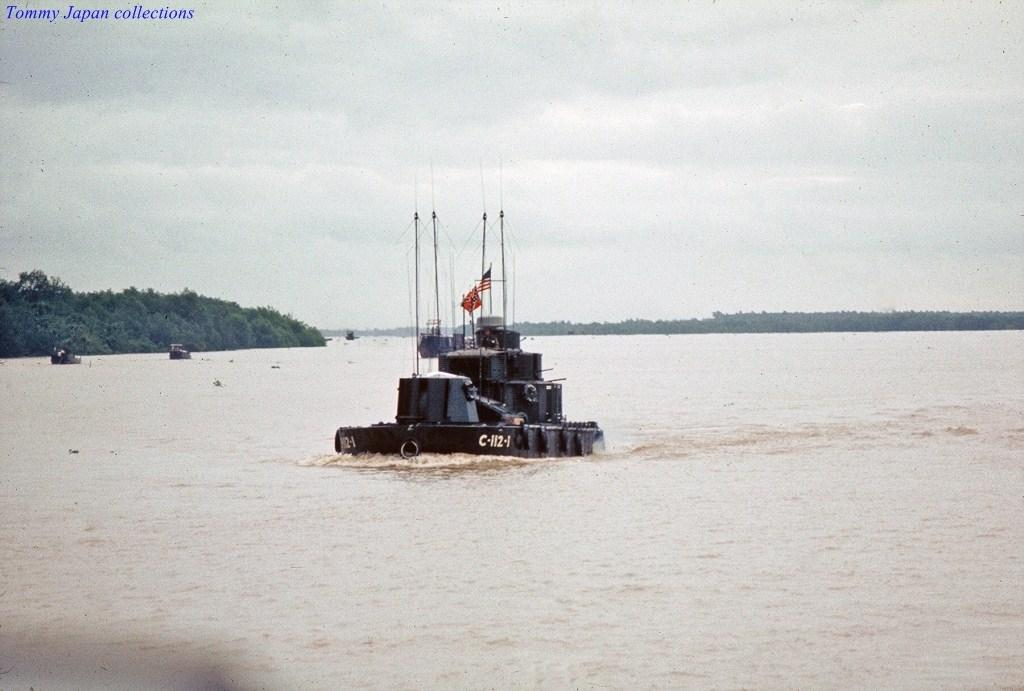<image>
Describe the image concisely. Black vehicle in the waters with the tag C-1121 on it. 